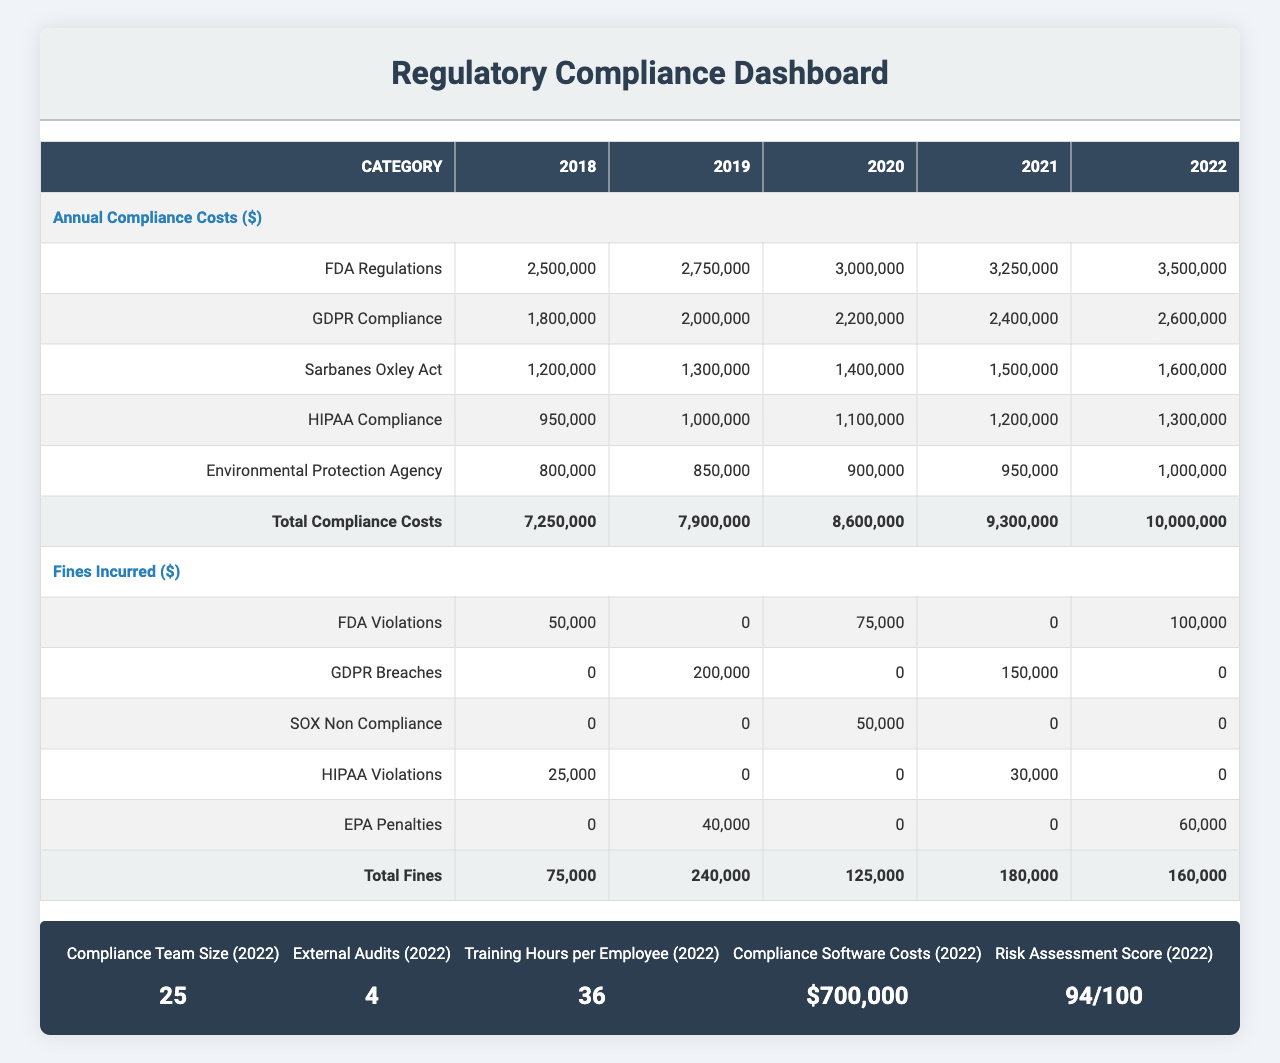what were the FDA regulatory compliance costs in 2020? The table shows that the FDA regulatory compliance costs for the year 2020 are $3,000,000.
Answer: $3,000,000 how much did we incur in GDPR breaches in 2019? According to the table, the fines incurred for GDPR breaches in 2019 are $200,000.
Answer: $200,000 what is the total compliance cost for 2022? To find the total compliance cost for 2022, we sum the compliance costs of all categories for that year: $3,500,000 (FDA) + $2,600,000 (GDPR) + $1,600,000 (Sarbanes-Oxley) + $1,300,000 (HIPAA) + $1,000,000 (EPA) = $10,000,000.
Answer: $10,000,000 which year had the highest total fines incurred? We check the total fines across the years: 2018 ($25,000), 2019 ($240,000), 2020 ($50,000), 2021 ($30,000), and 2022 ($60,000). The year 2019 had the highest total fines incurred at $240,000.
Answer: 2019 what is the average training hours per employee over the past five years? To find the average, we add the training hours for each year (20 + 24 + 28 + 32 + 36) = 140, then divide by the number of years: 140 / 5 = 28.
Answer: 28 did we incur any fines for HIPAA violations in 2018? Referring to the table, there was a fine of $25,000 for HIPAA violations in 2018.
Answer: Yes how did the total compliance costs trend from 2018 to 2022? The total compliance costs increased year over year: $8,350,000 (2018) to $10,000,000 (2022), showing a trend of rising costs each year.
Answer: Increasing what was the difference in total fines incurred between 2018 and 2022? Total fines in 2018 are $25,000 and in 2022 are $60,000. The difference is $60,000 - $25,000 = $35,000.
Answer: $35,000 how many external audits were conducted in total from 2018 to 2022? Adding the external audits conducted over the years gives us 2 + 3 + 3 + 4 + 4 = 16 total external audits.
Answer: 16 what percentage of the total compliance costs in 2022 did the FDA regulatory compliance costs represent? The FDA compliance costs in 2022 are $3,500,000 and the total compliance costs are $10,000,000. The percentage is ($3,500,000 / $10,000,000) * 100 = 35%.
Answer: 35% 